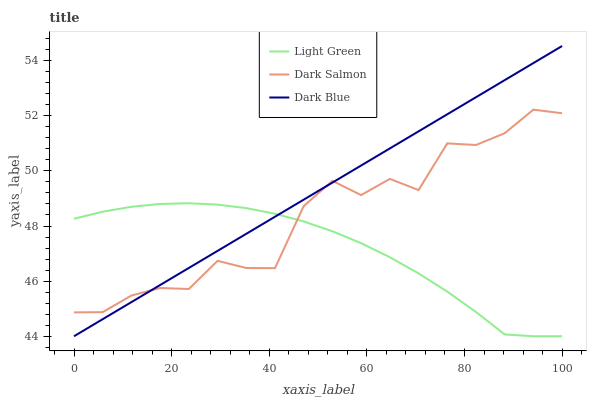Does Light Green have the minimum area under the curve?
Answer yes or no. Yes. Does Dark Blue have the maximum area under the curve?
Answer yes or no. Yes. Does Dark Salmon have the minimum area under the curve?
Answer yes or no. No. Does Dark Salmon have the maximum area under the curve?
Answer yes or no. No. Is Dark Blue the smoothest?
Answer yes or no. Yes. Is Dark Salmon the roughest?
Answer yes or no. Yes. Is Light Green the smoothest?
Answer yes or no. No. Is Light Green the roughest?
Answer yes or no. No. Does Dark Blue have the lowest value?
Answer yes or no. Yes. Does Dark Salmon have the lowest value?
Answer yes or no. No. Does Dark Blue have the highest value?
Answer yes or no. Yes. Does Dark Salmon have the highest value?
Answer yes or no. No. Does Dark Blue intersect Dark Salmon?
Answer yes or no. Yes. Is Dark Blue less than Dark Salmon?
Answer yes or no. No. Is Dark Blue greater than Dark Salmon?
Answer yes or no. No. 